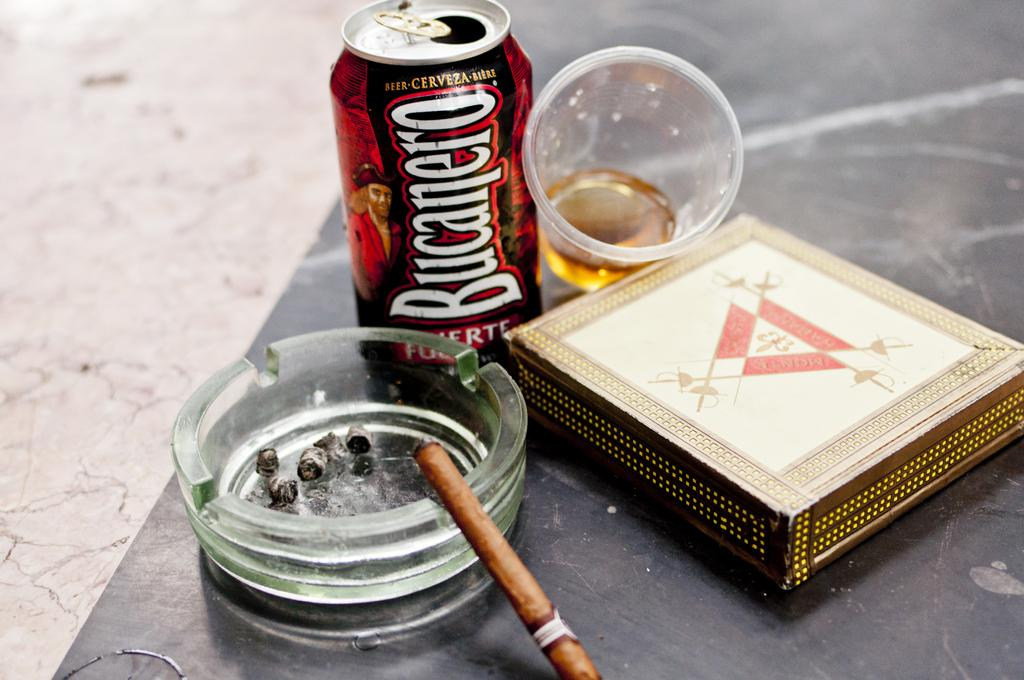<image>
Present a compact description of the photo's key features. A can of BUCANERO beer is pictured near an ashtray, cup with beer in it, and a box. 